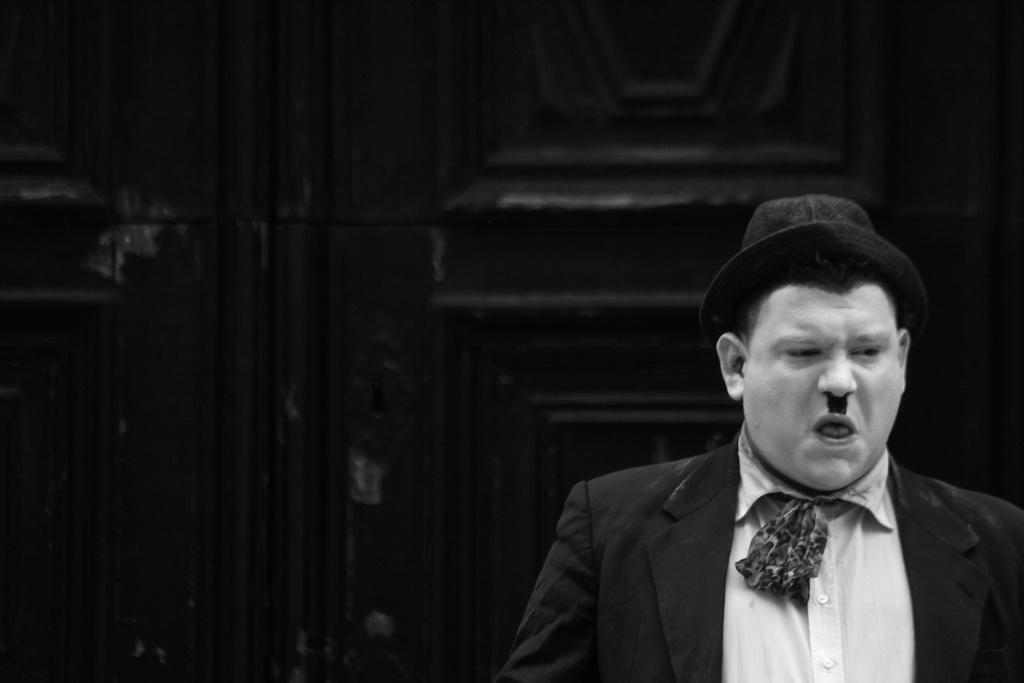What is the color scheme of the image? The image is black and white. Can you describe the main subject in the image? There is a person in the image. What is the person's location in the image? The person is in front of a wall. What is the person wearing in the image? The person is wearing clothes and a hat. Can you hear the chicken laughing in the image? There is no chicken or laughter present in the image, as it is a black and white image of a person in front of a wall. 